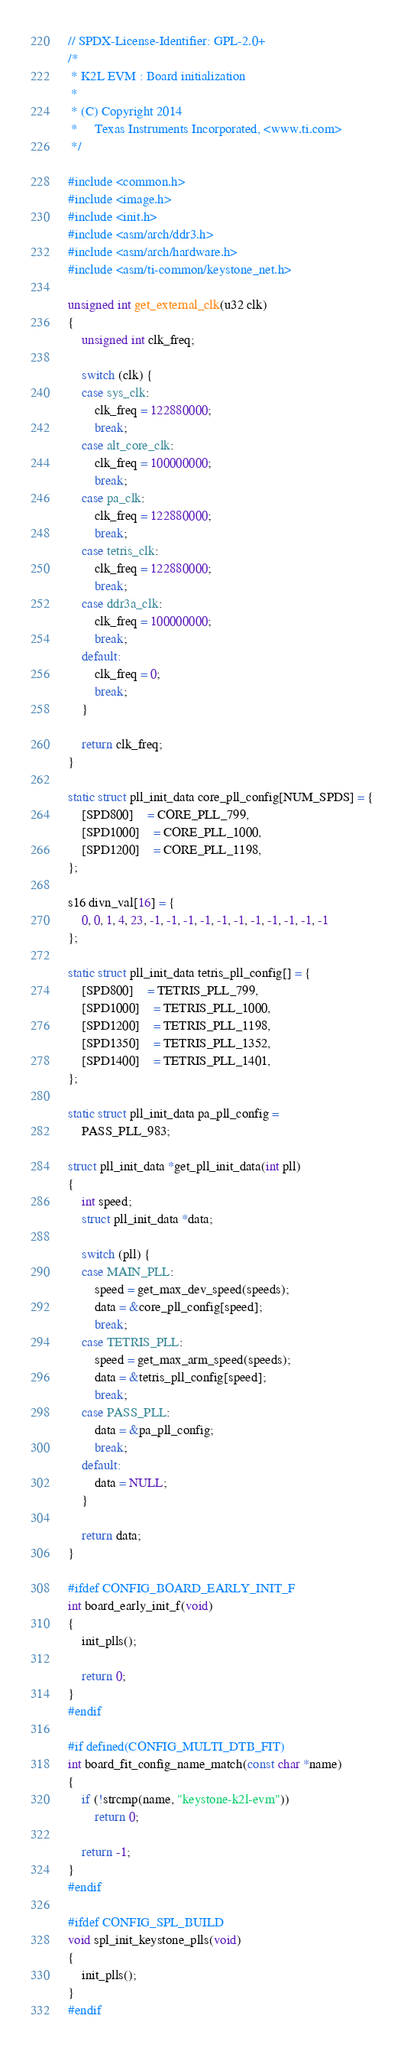Convert code to text. <code><loc_0><loc_0><loc_500><loc_500><_C_>// SPDX-License-Identifier: GPL-2.0+
/*
 * K2L EVM : Board initialization
 *
 * (C) Copyright 2014
 *     Texas Instruments Incorporated, <www.ti.com>
 */

#include <common.h>
#include <image.h>
#include <init.h>
#include <asm/arch/ddr3.h>
#include <asm/arch/hardware.h>
#include <asm/ti-common/keystone_net.h>

unsigned int get_external_clk(u32 clk)
{
	unsigned int clk_freq;

	switch (clk) {
	case sys_clk:
		clk_freq = 122880000;
		break;
	case alt_core_clk:
		clk_freq = 100000000;
		break;
	case pa_clk:
		clk_freq = 122880000;
		break;
	case tetris_clk:
		clk_freq = 122880000;
		break;
	case ddr3a_clk:
		clk_freq = 100000000;
		break;
	default:
		clk_freq = 0;
		break;
	}

	return clk_freq;
}

static struct pll_init_data core_pll_config[NUM_SPDS] = {
	[SPD800]	= CORE_PLL_799,
	[SPD1000]	= CORE_PLL_1000,
	[SPD1200]	= CORE_PLL_1198,
};

s16 divn_val[16] = {
	0, 0, 1, 4, 23, -1, -1, -1, -1, -1, -1, -1, -1, -1, -1, -1
};

static struct pll_init_data tetris_pll_config[] = {
	[SPD800]	= TETRIS_PLL_799,
	[SPD1000]	= TETRIS_PLL_1000,
	[SPD1200]	= TETRIS_PLL_1198,
	[SPD1350]	= TETRIS_PLL_1352,
	[SPD1400]	= TETRIS_PLL_1401,
};

static struct pll_init_data pa_pll_config =
	PASS_PLL_983;

struct pll_init_data *get_pll_init_data(int pll)
{
	int speed;
	struct pll_init_data *data;

	switch (pll) {
	case MAIN_PLL:
		speed = get_max_dev_speed(speeds);
		data = &core_pll_config[speed];
		break;
	case TETRIS_PLL:
		speed = get_max_arm_speed(speeds);
		data = &tetris_pll_config[speed];
		break;
	case PASS_PLL:
		data = &pa_pll_config;
		break;
	default:
		data = NULL;
	}

	return data;
}

#ifdef CONFIG_BOARD_EARLY_INIT_F
int board_early_init_f(void)
{
	init_plls();

	return 0;
}
#endif

#if defined(CONFIG_MULTI_DTB_FIT)
int board_fit_config_name_match(const char *name)
{
	if (!strcmp(name, "keystone-k2l-evm"))
		return 0;

	return -1;
}
#endif

#ifdef CONFIG_SPL_BUILD
void spl_init_keystone_plls(void)
{
	init_plls();
}
#endif
</code> 